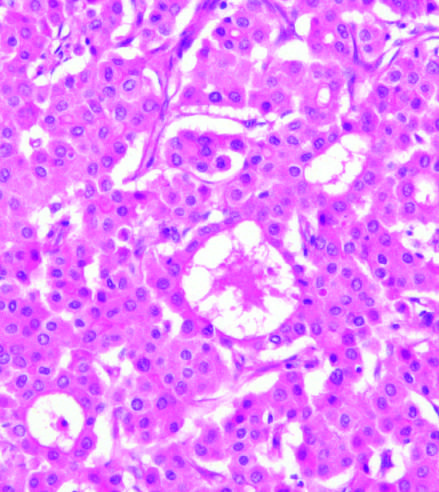what grows in distorted versions of normal architecture : large pseudoacinar spaces, essentially malformed, dilated bile canaliculi?
Answer the question using a single word or phrase. Malignant hepatocytes 